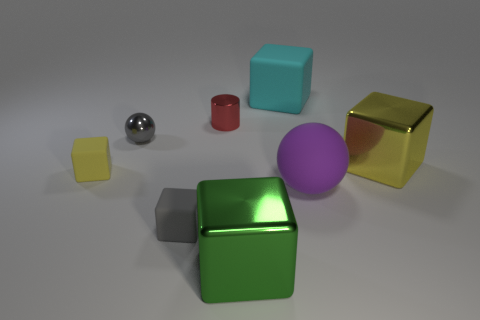There is a tiny matte object that is the same color as the tiny ball; what is its shape?
Provide a succinct answer. Cube. What is the material of the purple object that is the same size as the green metallic thing?
Ensure brevity in your answer.  Rubber. What size is the yellow matte thing that is on the left side of the yellow object to the right of the tiny object right of the tiny gray rubber object?
Provide a succinct answer. Small. How many other things are there of the same material as the large cyan thing?
Keep it short and to the point. 3. There is a shiny thing in front of the yellow matte block; how big is it?
Provide a short and direct response. Large. How many large cubes are both in front of the red metallic thing and right of the green cube?
Give a very brief answer. 1. What material is the ball right of the metallic cube that is in front of the purple sphere?
Offer a terse response. Rubber. There is a purple object that is the same shape as the gray shiny object; what is it made of?
Ensure brevity in your answer.  Rubber. Are there any small purple cubes?
Provide a short and direct response. No. There is a big cyan thing that is the same material as the gray block; what is its shape?
Ensure brevity in your answer.  Cube. 